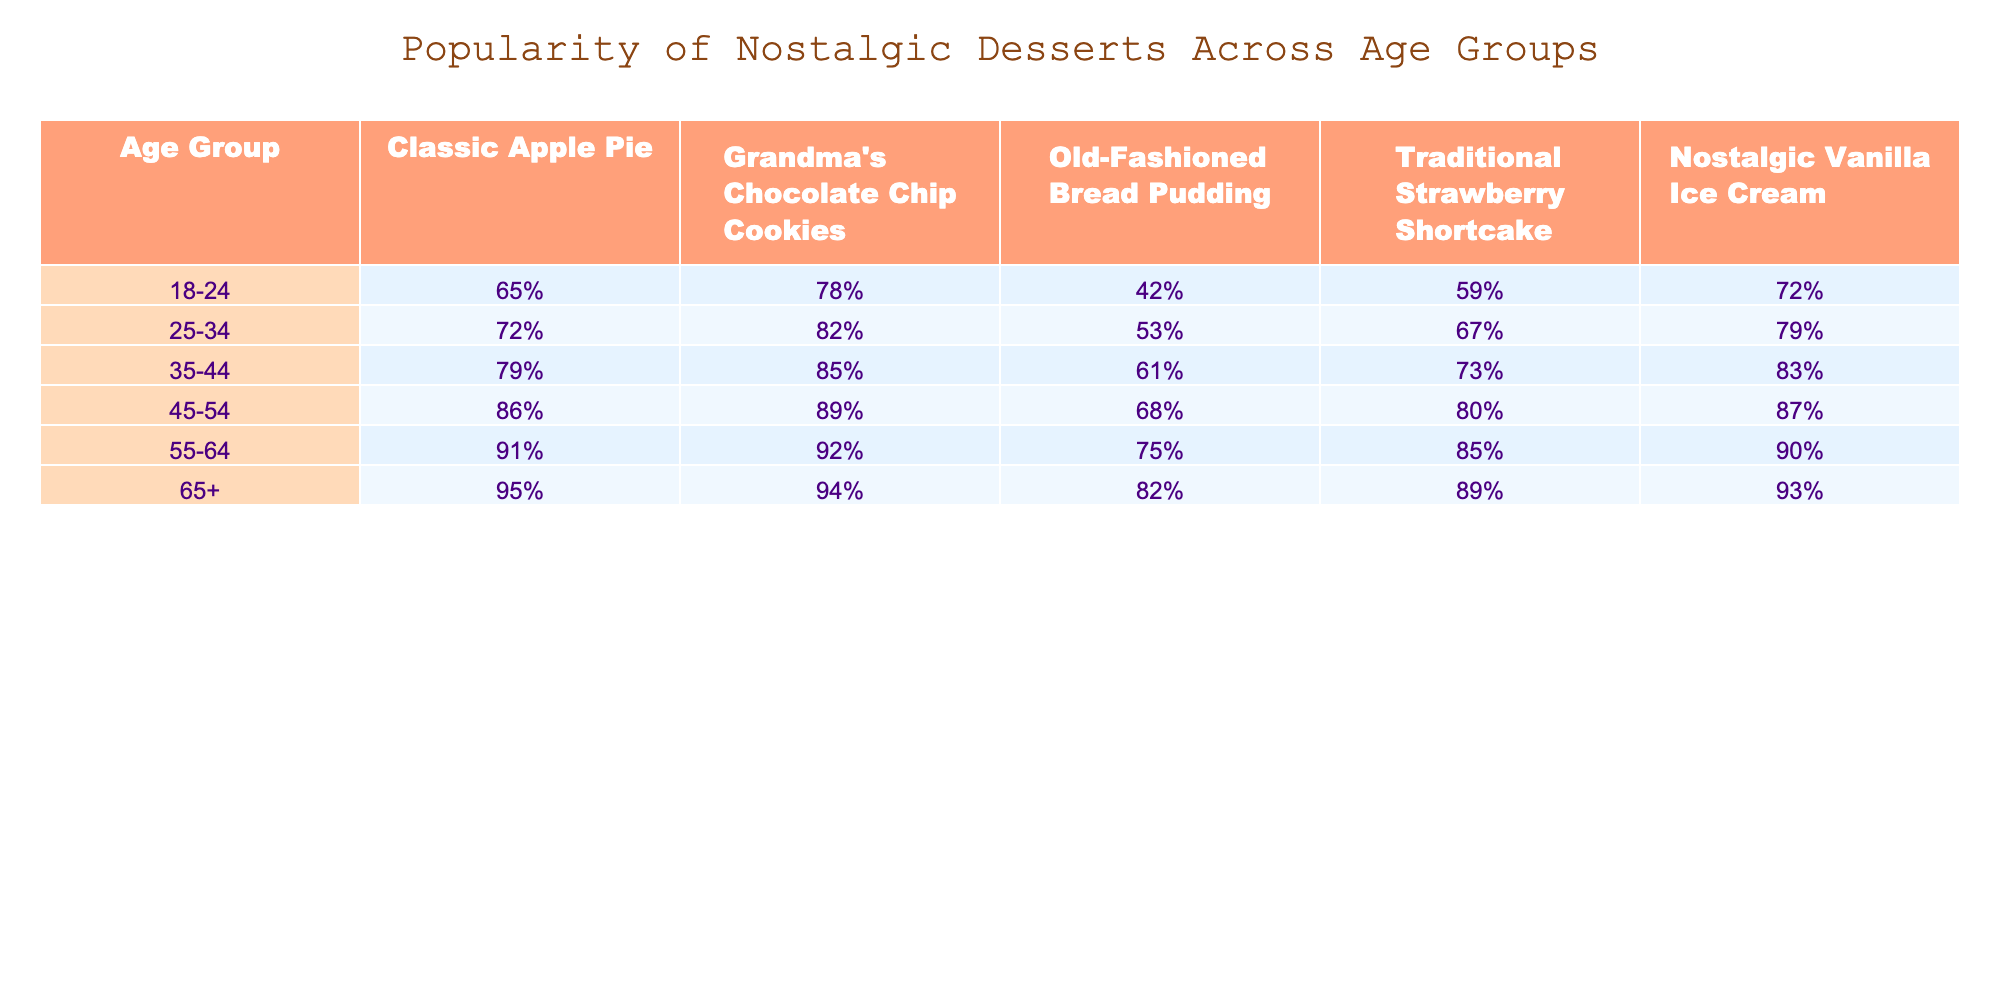What age group has the highest percentage of fans for Traditional Strawberry Shortcake? The highest percentage for Traditional Strawberry Shortcake is in the 65+ age group at 89%.
Answer: 65+ What percentage of 35-44 year-olds prefer Grandma's Chocolate Chip Cookies? According to the table, 85% of the 35-44 age group prefer Grandma's Chocolate Chip Cookies.
Answer: 85% Is the popularity of Old-Fashioned Bread Pudding higher among 45-54 year-olds than among 25-34 year-olds? For 45-54 year-olds, the percentage is 68%, while for 25-34 year-olds it is 53%. Since 68% is higher than 53%, the statement is true.
Answer: Yes What is the average popularity of Classic Apple Pie across all age groups? The values for Classic Apple Pie are: 65%, 72%, 79%, 86%, 91%, and 95%. Summing these gives us 65 + 72 + 79 + 86 + 91 + 95 = 488. Dividing by 6 (the number of age groups), we get an average of 81.33%.
Answer: 81.33% Which nostalgic dessert is most popular among the 55-64 age group? For the 55-64 age group, the highest percentage goes to Grandma's Chocolate Chip Cookies at 92%.
Answer: Grandma's Chocolate Chip Cookies 